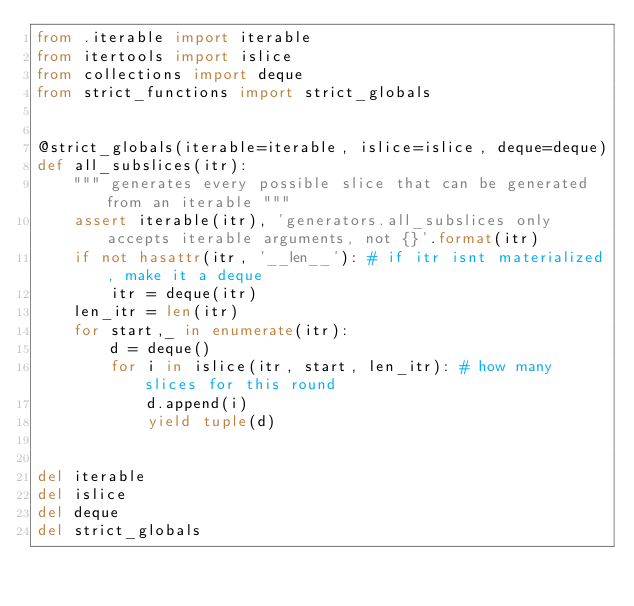<code> <loc_0><loc_0><loc_500><loc_500><_Python_>from .iterable import iterable
from itertools import islice
from collections import deque
from strict_functions import strict_globals


@strict_globals(iterable=iterable, islice=islice, deque=deque)
def all_subslices(itr):
    """ generates every possible slice that can be generated from an iterable """
    assert iterable(itr), 'generators.all_subslices only accepts iterable arguments, not {}'.format(itr)
    if not hasattr(itr, '__len__'): # if itr isnt materialized, make it a deque
        itr = deque(itr)
    len_itr = len(itr)
    for start,_ in enumerate(itr):
        d = deque()
        for i in islice(itr, start, len_itr): # how many slices for this round
            d.append(i)
            yield tuple(d)


del iterable
del islice
del deque
del strict_globals
</code> 